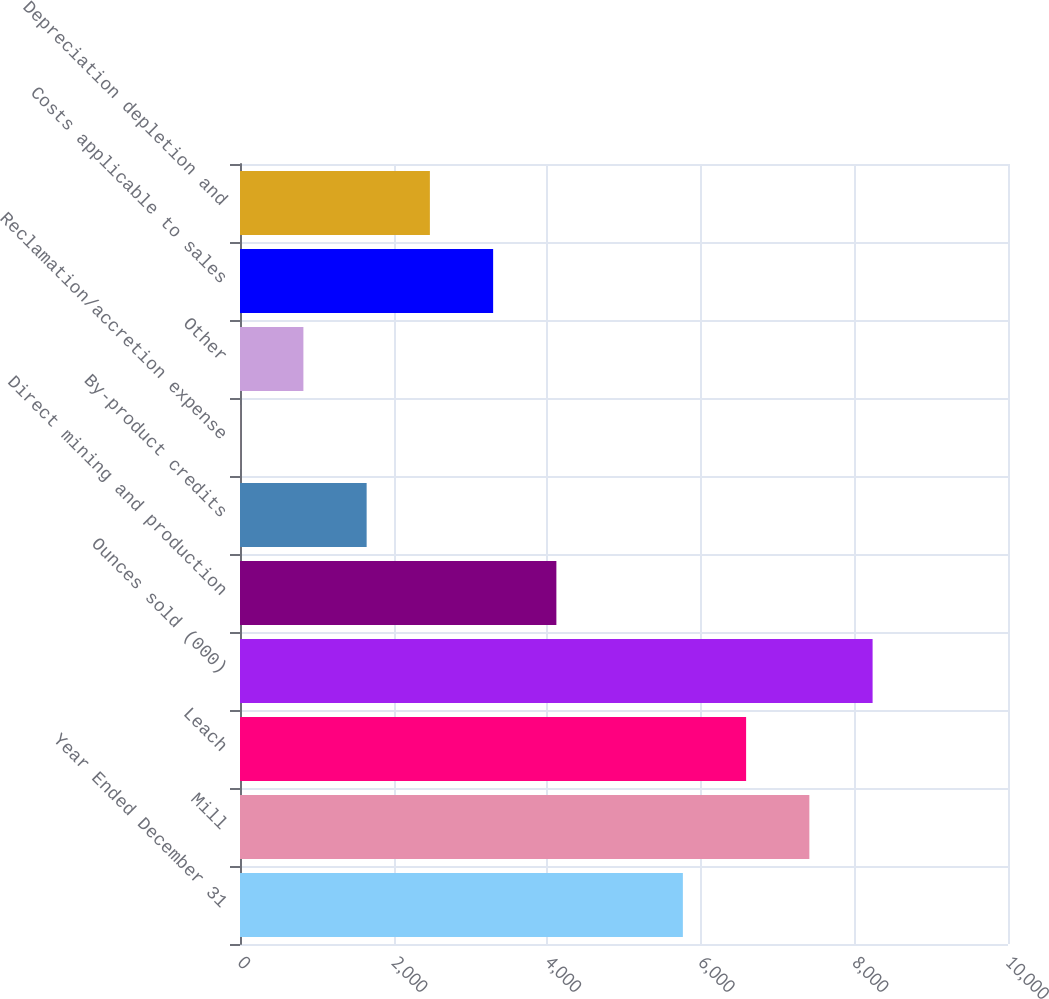Convert chart. <chart><loc_0><loc_0><loc_500><loc_500><bar_chart><fcel>Year Ended December 31<fcel>Mill<fcel>Leach<fcel>Ounces sold (000)<fcel>Direct mining and production<fcel>By-product credits<fcel>Reclamation/accretion expense<fcel>Other<fcel>Costs applicable to sales<fcel>Depreciation depletion and<nl><fcel>5766.5<fcel>7413.5<fcel>6590<fcel>8237<fcel>4119.5<fcel>1649<fcel>2<fcel>825.5<fcel>3296<fcel>2472.5<nl></chart> 